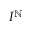Convert formula to latex. <formula><loc_0><loc_0><loc_500><loc_500>I ^ { \mathbb { N } }</formula> 